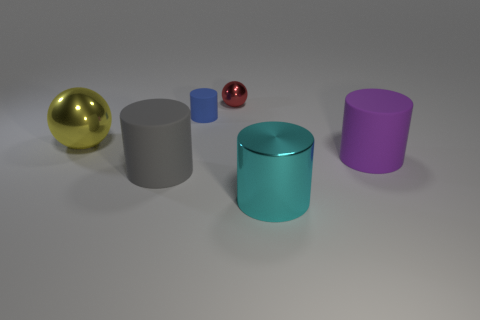Subtract 1 cylinders. How many cylinders are left? 3 Add 3 big purple rubber cylinders. How many objects exist? 9 Subtract all cylinders. How many objects are left? 2 Add 1 cyan objects. How many cyan objects exist? 2 Subtract 0 brown balls. How many objects are left? 6 Subtract all small green spheres. Subtract all red shiny balls. How many objects are left? 5 Add 4 large purple cylinders. How many large purple cylinders are left? 5 